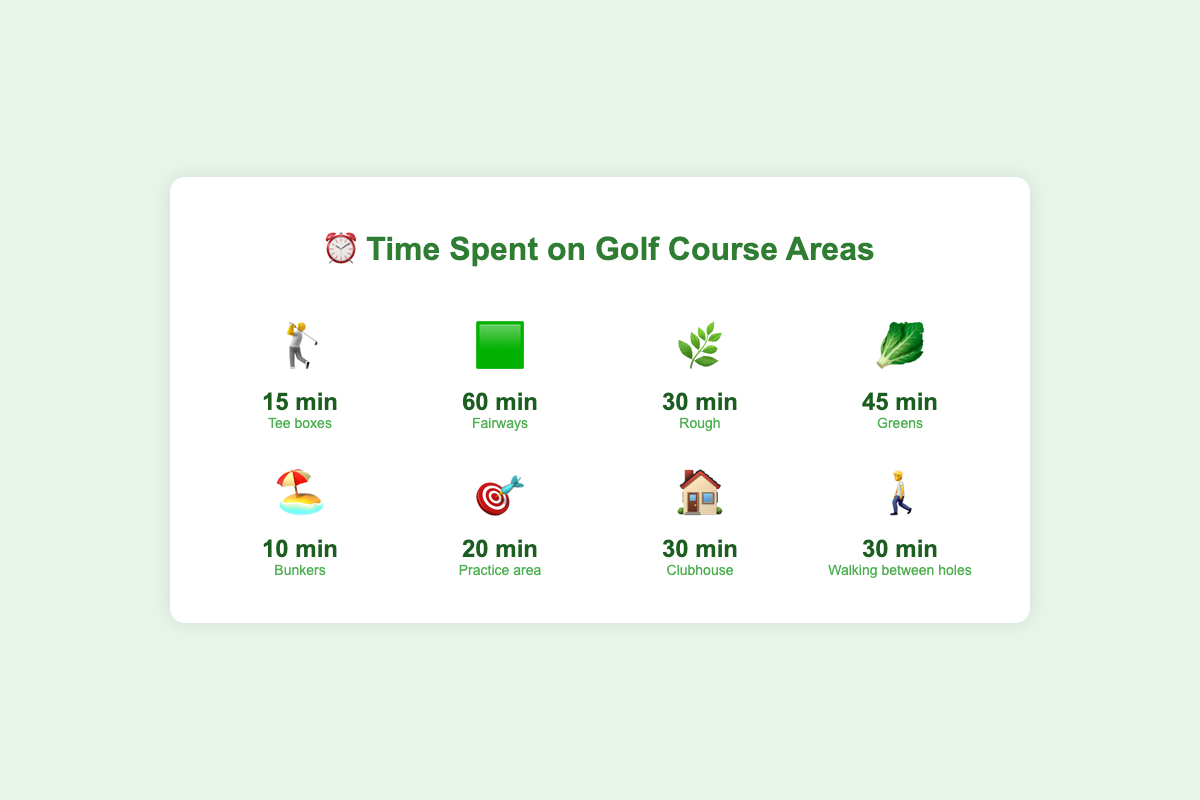What is the total time spent on the fairways (🟩)? The figure shows time spent on fairways as 60 minutes.
Answer: 60 minutes Which course area has the shortest time spent? By looking at each area and the times, the bunkers (🏖️) have the shortest time spent at 10 minutes.
Answer: Bunkers (10 minutes) How much more time is spent on the greens (🥬) compared to the tee boxes (🏌️)? Time spent on the greens is 45 minutes, and on the tee boxes is 15 minutes. The difference is 45 - 15 = 30 minutes.
Answer: 30 minutes What's the combined time spent on the rough (🌿) and walking between holes (🚶)? Time spent on the rough is 30 minutes, and walking between holes is also 30 minutes. The total time is 30 + 30 = 60 minutes.
Answer: 60 minutes List all course areas with a time of exactly 30 minutes. Checking the figure, the rough (🌿), clubhouse (🏠), and walking between holes (🚶) each have 30 minutes.
Answer: Rough, Clubhouse, Walking between holes Which area has the most time spent, and how much is it? By comparing the times visually, the fairways (🟩) have the most time spent at 60 minutes.
Answer: Fairways (60 minutes) Is more time spent in the clubhouse (🏠) or practice area (🎯)? Clubhouse time is 30 minutes, and practice area time is 20 minutes. So, more time is spent in the clubhouse.
Answer: Clubhouse What is the average time spent across all course areas? Adding up all times: 15 (Tee boxes) + 60 (Fairways) + 30 (Rough) + 45 (Greens) + 10 (Bunkers) + 20 (Practice area) + 30 (Clubhouse) + 30 (Walking) = 240 minutes. The average is 240 / 8 = 30 minutes.
Answer: 30 minutes Rank the top three areas where the most time is spent. Checking all times, the top three are fairways (60 minutes), greens (45 minutes), and a tie between rough, clubhouse, and walking between holes (all 30 minutes).
Answer: Fairways, Greens, Rough/Clubhouse/Walking What is the total time spent excluding the fairways (🟩)? The total time from all areas is 240 minutes. Subtracting the time for fairways (60 minutes): 240 - 60 = 180 minutes.
Answer: 180 minutes 